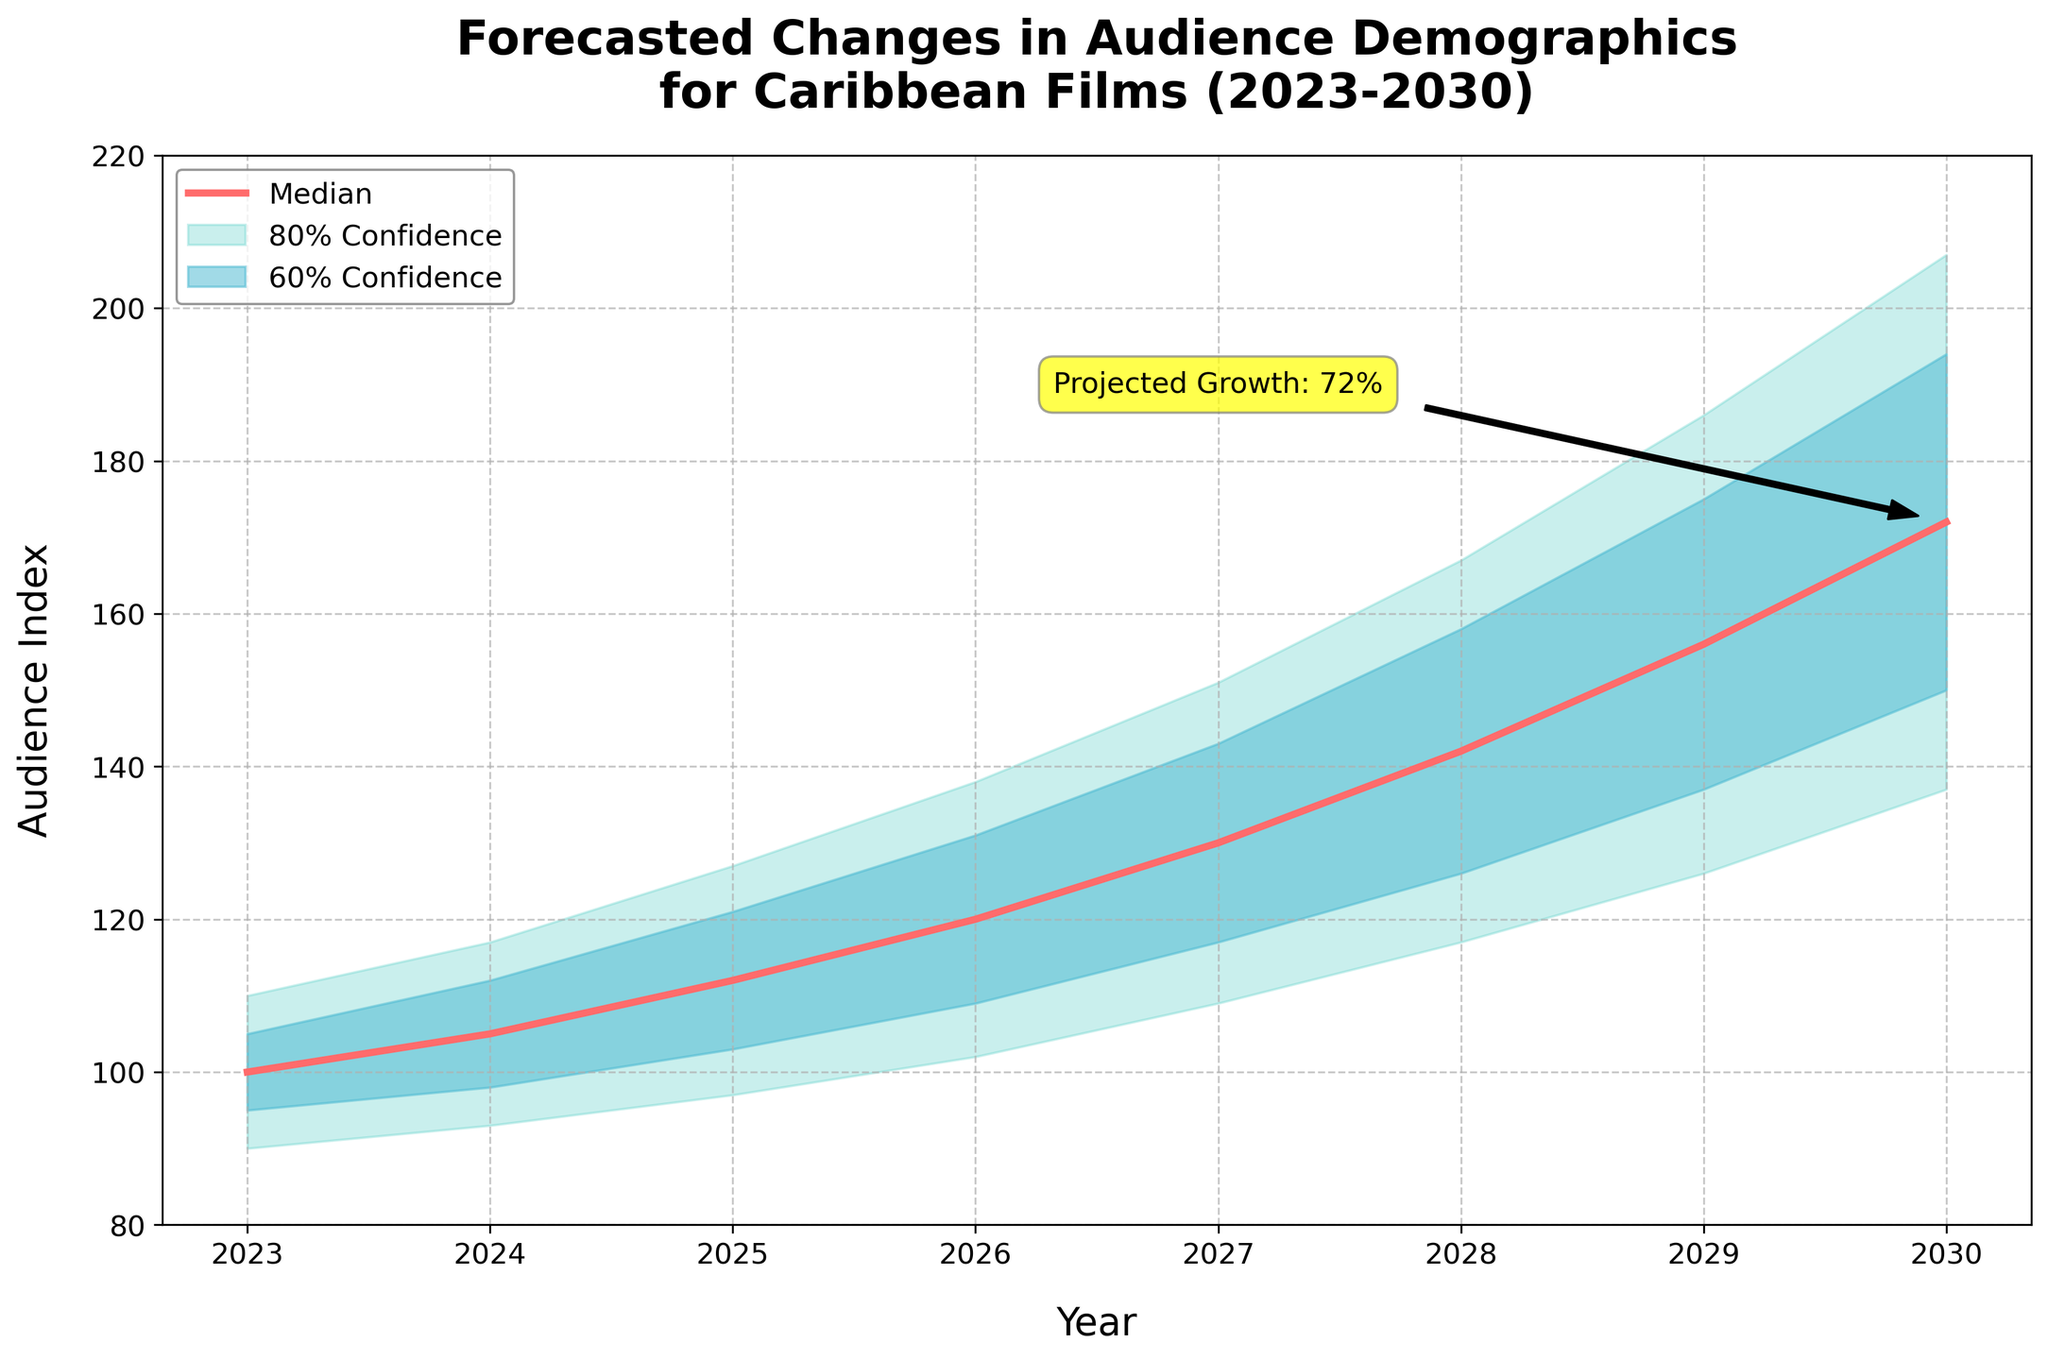What's the title of the chart? The title is stated at the top of the chart. It provides an overview of the data being represented.
Answer: Forecasted Changes in Audience Demographics for Caribbean Films (2023-2030) What is the median audience index forecasted for 2027? To find the median audience index for 2027, locate 2027 on the x-axis and find the corresponding point on the median line.
Answer: 130 What are the boundaries of the 80% confidence interval for the year 2026? Identify 2026 on the x-axis and look at the shaded area representing the 80% confidence interval. The lower boundary (Low_20) and upper boundary (High_20) values determine this interval.
Answer: 102 to 138 What is the difference between the median audience index forecast for 2029 and 2025? Identify the median values for 2029 and 2025 from the median line. Subtract the 2025 value from the 2029 value to find the difference.
Answer: (156 - 112) = 44 Which year has the widest 80% confidence interval? Calculate the width of the 80% confidence interval for each year by subtracting the Low_20 value from the High_20 value. The year with the largest resultant value has the widest interval.
Answer: 2030 (207 - 137 = 70) How does the median forecasted audience index change from 2023 to 2030? Identify the median audience index values for both 2023 and 2030 and compare them to see how they change over time.
Answer: It increases from 100 to 172 What's the projected percentage growth from 2023 to 2030 in the median audience index? Calculate the percentage growth using the formula: (Value in 2030 - Value in 2023) / Value in 2023 * 100%.
Answer: ((172 - 100) / 100) * 100% = 72% Which year shows an upward trend in the median audience index compared to the previous year? Compare the median values year by year. Any year where the median value is higher than the previous year's value reflects an upward trend.
Answer: Every year shows an upward trend How do the boundaries of the 60% confidence interval compare in 2025 and 2028? Identify the 60% confidence interval bounds (Low_10 and High_10) for both years and compare them directly.
Answer: 2025: 103 to 121, 2028: 126 to 158 What annotation is displayed on the chart, and what does it signify? Look for text and arrows added to the chart as annotations to understand their message. The annotation includes text and potentially an arrow pointing to a specific data point.
Answer: "Projected Growth: 72%", indicating the overall median forecasted growth from 2023 to 2030 